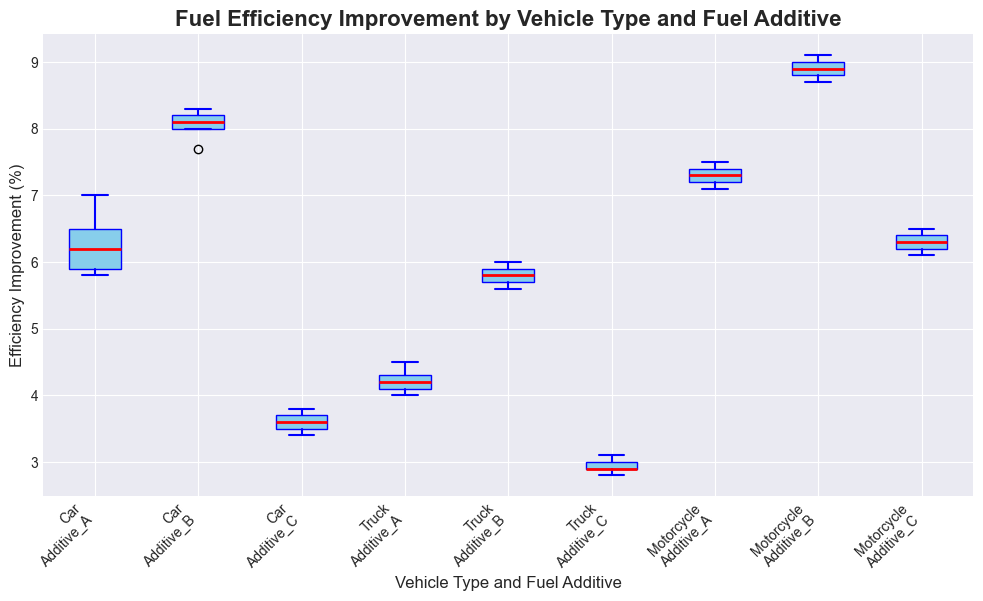What is the median efficiency improvement for cars using Additive B? To determine the median efficiency improvement for cars using Additive B, locate the box plot for Additive B under the Car category. The median is indicated by the red line inside the box.
Answer: 8.0% Which vehicle type and additive combination shows the highest median efficiency improvement? Compare the median lines (red) across all the combinations. The highest median line corresponds to the motorcycle type with Additive B.
Answer: Motorcycle with Additive B Which vehicle type has the smallest interquartile range (IQR) for any additive? The IQR is the height of the box in the box plot. Inspect the heights of the boxes across all combinations. The smallest box corresponds to trucks using Additive C.
Answer: Truck with Additive C What is the difference in median efficiency improvement between trucks using Additive A and Additive B? Locate the median lines for trucks using Additive A and Additive B. The difference is the absolute difference between these median values. The median for Additive A is 4.2%, and for Additive B is 5.8%. The difference is 5.8% - 4.2%.
Answer: 1.6% Which additive has the most consistent performance across all vehicle types? Consistency can be interpreted as having similar IQRs and medians across all vehicle types. Evaluate the box plots for each additive across different vehicles. Additive B shows relatively consistent IQRs and medians across cars, trucks, and motorcycles.
Answer: Additive B Which combination has the highest range in efficiency improvements? The range is the difference between the maximum and minimum values (whiskers) in the box plot. Examine the whiskers of each plot to determine the largest range. Cars with Additive B have the highest range.
Answer: Car with Additive B How does the median efficiency improvement for cars using Additive C compare to motorcycles using Additive C? Compare the median lines for cars using Additive C and motorcycles using Additive C. The median for cars is lower than that for motorcycles.
Answer: Lower What is the efficiency improvement range for motorcycles using Additive A? The range is given by the distance between the bottom whisker (minimum) and the top whisker (maximum) of the box plot. Look at the box plot for motorcycles using Additive A. The minimum value is 7.1% and the maximum is 7.5%.
Answer: 0.4% Which vehicle type and additive combination has the least median efficiency improvement? Identify the combination with the lowest median line (red line). The combination with the lowest median is trucks using Additive C.
Answer: Truck with Additive C 